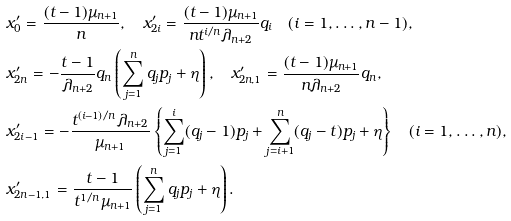<formula> <loc_0><loc_0><loc_500><loc_500>& x ^ { \prime } _ { 0 } = \frac { ( t - 1 ) \mu _ { n + 1 } } { n } , \quad x ^ { \prime } _ { 2 i } = \frac { ( t - 1 ) \mu _ { n + 1 } } { n t ^ { i / n } \lambda _ { n + 2 } } q _ { i } \quad ( i = 1 , \dots , n - 1 ) , \\ & x ^ { \prime } _ { 2 n } = - \frac { t - 1 } { \lambda _ { n + 2 } } q _ { n } \left ( \sum _ { j = 1 } ^ { n } q _ { j } p _ { j } + \eta \right ) , \quad x ^ { \prime } _ { 2 n , 1 } = \frac { ( t - 1 ) \mu _ { n + 1 } } { n \lambda _ { n + 2 } } q _ { n } , \\ & x ^ { \prime } _ { 2 i - 1 } = - \frac { t ^ { ( i - 1 ) / n } \lambda _ { n + 2 } } { \mu _ { n + 1 } } \left \{ \sum _ { j = 1 } ^ { i } ( q _ { j } - 1 ) p _ { j } + \sum _ { j = i + 1 } ^ { n } ( q _ { j } - t ) p _ { j } + \eta \right \} \quad ( i = 1 , \dots , n ) , \\ & x ^ { \prime } _ { 2 n - 1 , 1 } = \frac { t - 1 } { t ^ { 1 / n } \mu _ { n + 1 } } \left ( \sum _ { j = 1 } ^ { n } q _ { j } p _ { j } + \eta \right ) .</formula> 